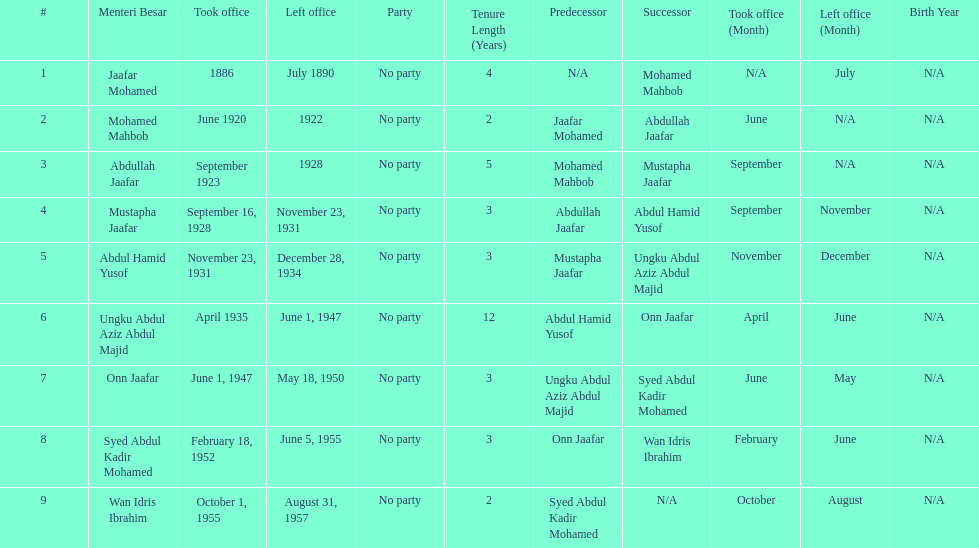Who was in office previous to abdullah jaafar? Mohamed Mahbob. 